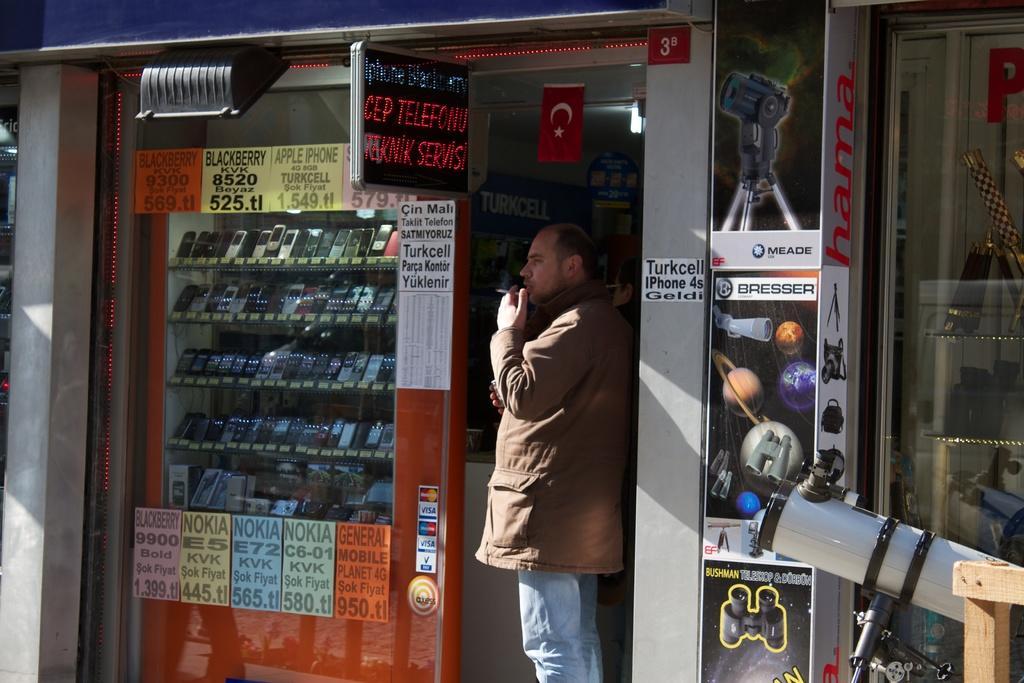Could you give a brief overview of what you see in this image? In this image I can see a person wearing brown jacket and blue jeans is standing and holding a cigarette. I can see a store in which I can see number of mobiles in the racks, few posts attached to the walls, a board, a light and a white and black colored object to the right side of the image. In the background I can see the ceiling, a light to the ceiling and a red colored flag. 